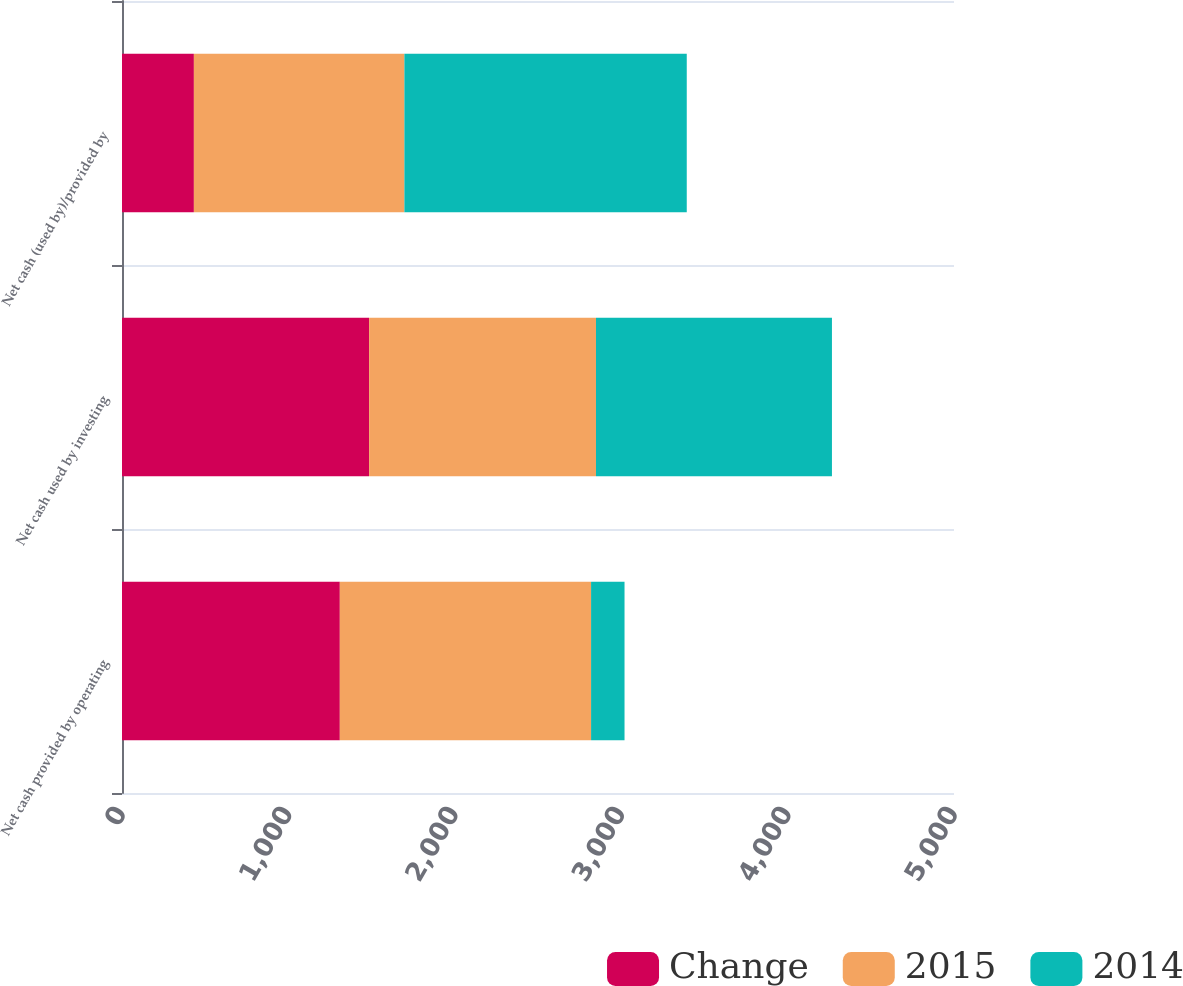Convert chart to OTSL. <chart><loc_0><loc_0><loc_500><loc_500><stacked_bar_chart><ecel><fcel>Net cash provided by operating<fcel>Net cash used by investing<fcel>Net cash (used by)/provided by<nl><fcel>Change<fcel>1309<fcel>1485<fcel>432<nl><fcel>2015<fcel>1510<fcel>1363.5<fcel>1265<nl><fcel>2014<fcel>201<fcel>1418<fcel>1697<nl></chart> 